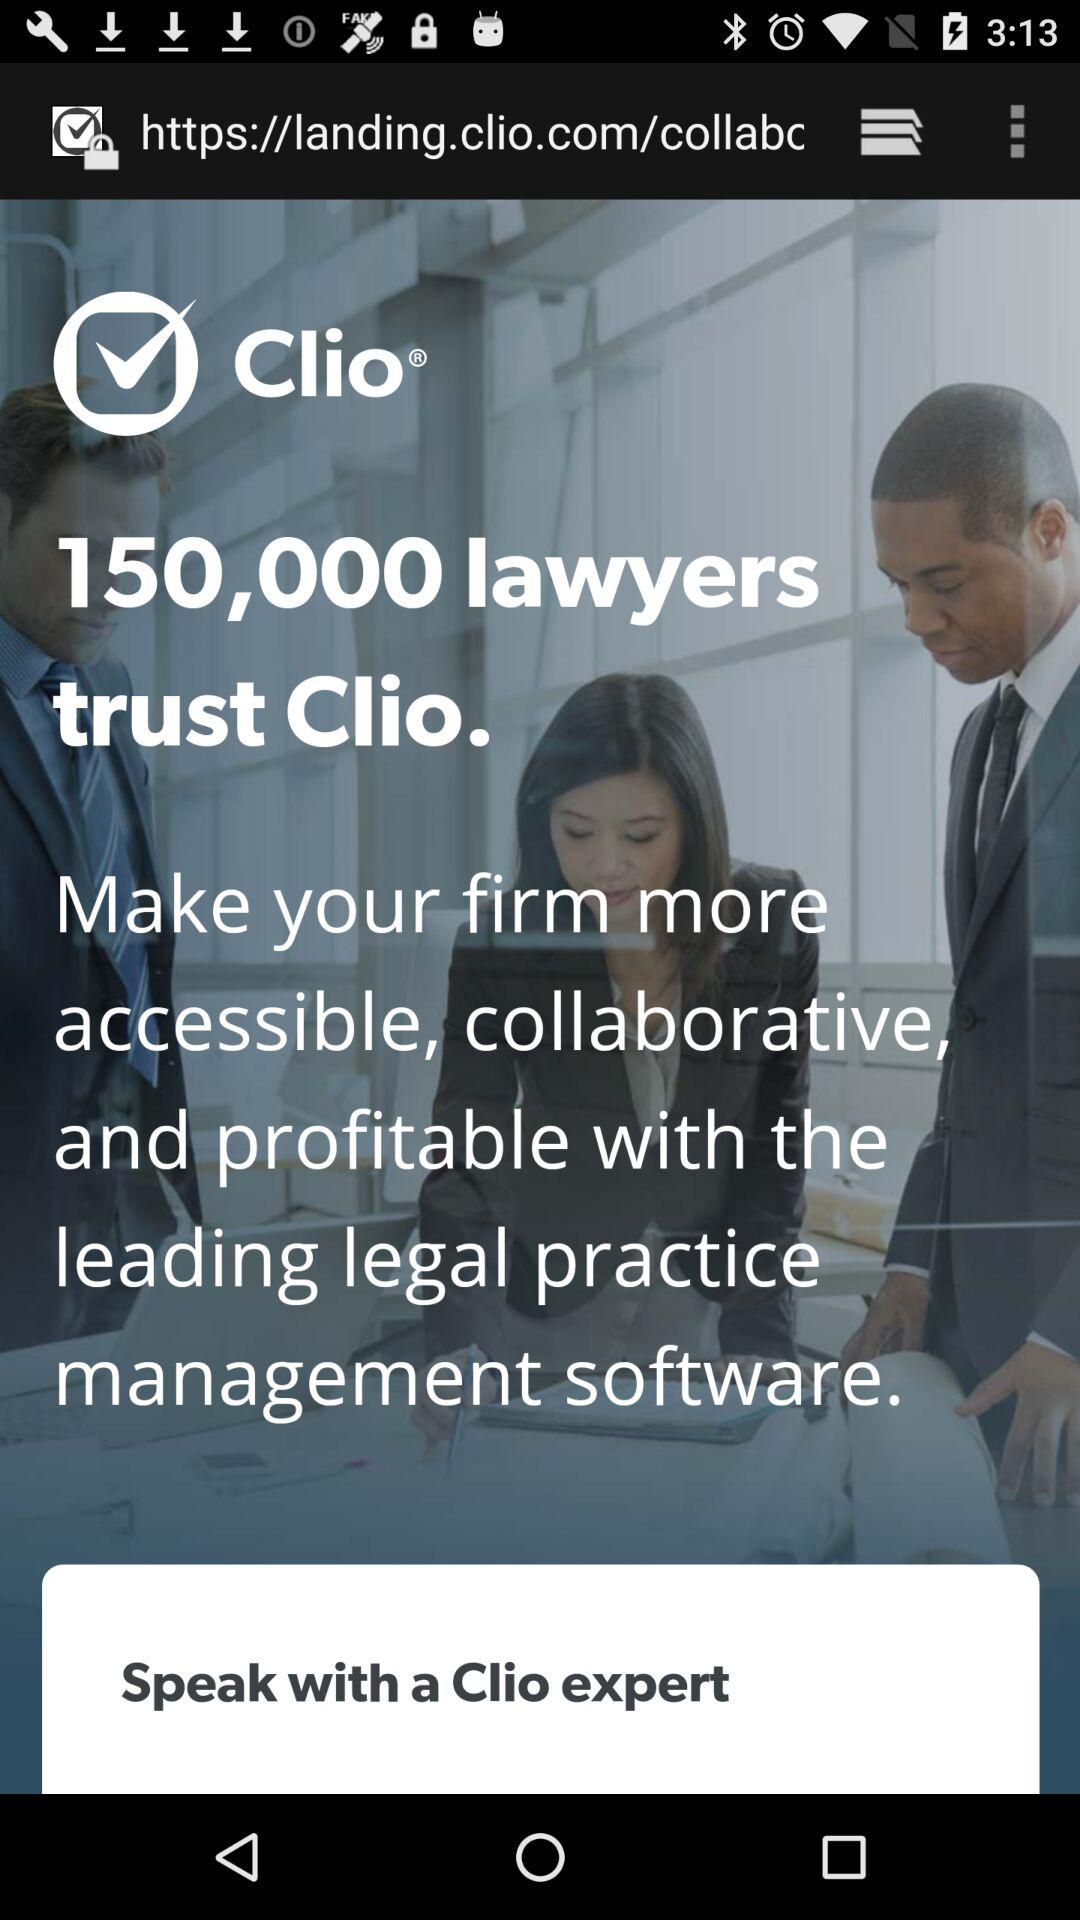What is the number of lawyers who trust "Clio"? The number of lawyers who trust "Clio" is 150,000. 